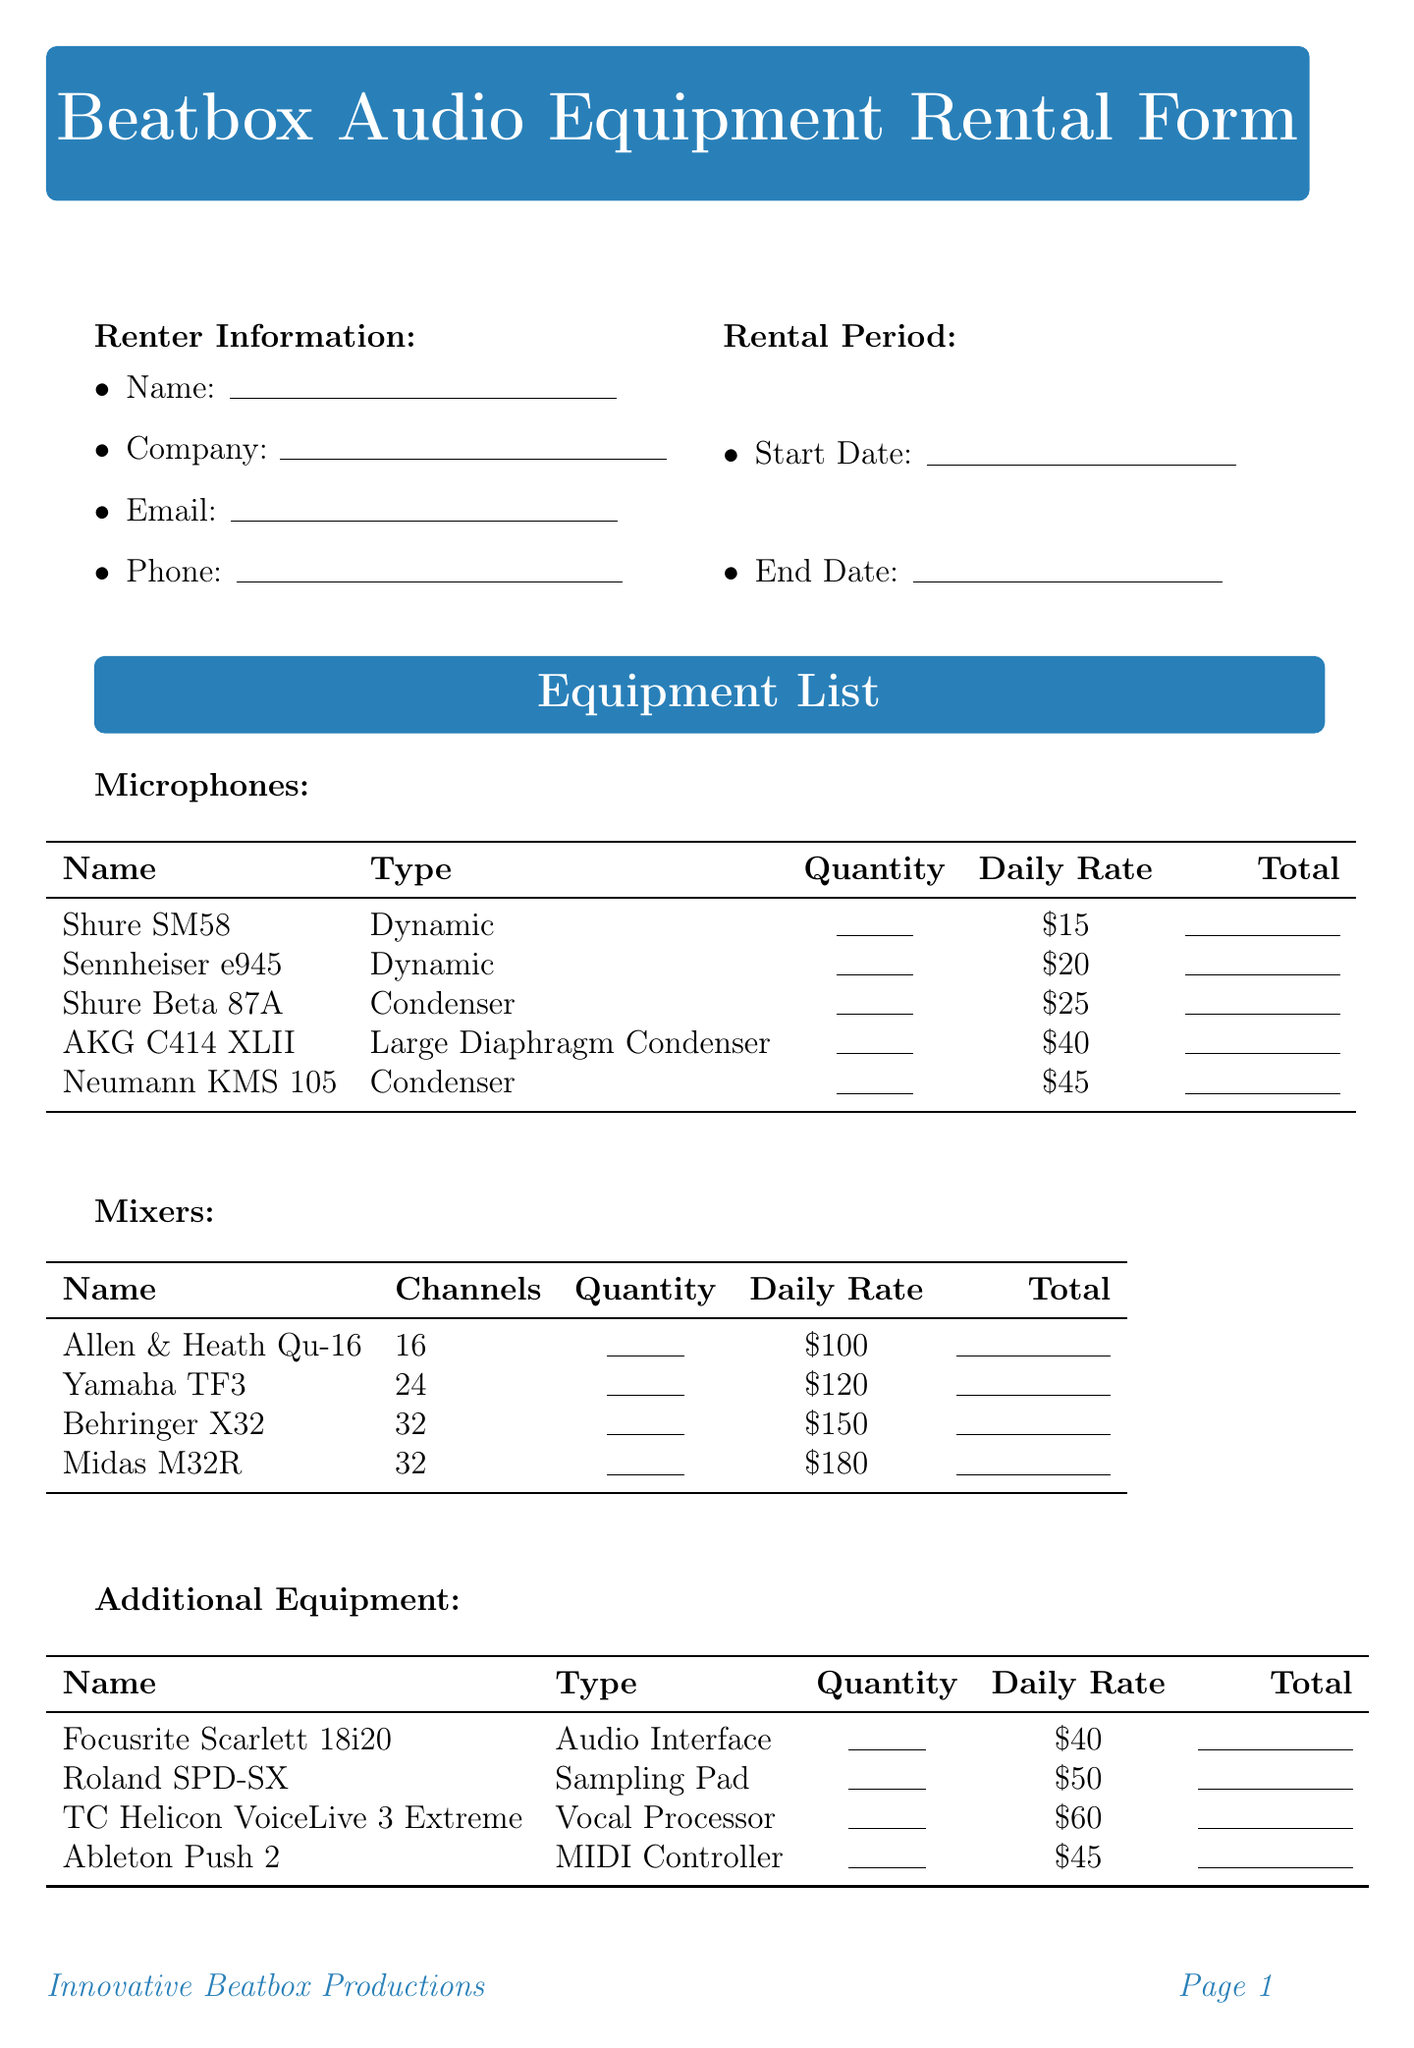what is the title of the form? The title is stated at the top of the document.
Answer: Beatbox Audio Equipment Rental Form who is responsible for any damage or loss of equipment? This information can be found in the terms and conditions section.
Answer: Renter what is the daily rate for the Neumann KMS 105 microphone? This price can be found in the equipment list under microphones.
Answer: 45 how many channels does the Behringer X32 mixer have? The number of channels is specified in the equipment list under mixers.
Answer: 32 what is the rental start date? There is a field for this information in the rental period section.
Answer: (blank) what happens if there is a cancellation within 24 hours of the rental period? The terms and conditions provide this information.
Answer: 50 percent fee what is the daily rate for the Focusrite Scarlett 18i20? This is listed in the additional equipment section of the document.
Answer: 40 how many microphones are listed in the document? This can be counted from the equipment list under microphones.
Answer: 5 is there a special request section in the form? The details regarding special requests can be found in the form layout.
Answer: Yes 